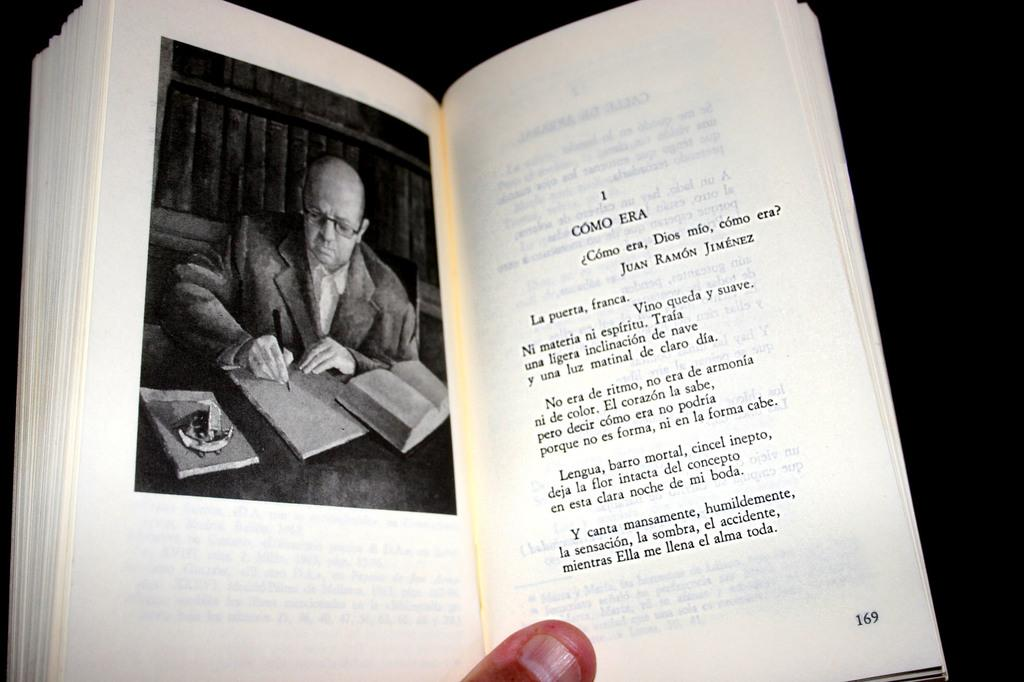<image>
Offer a succinct explanation of the picture presented. An open French book showing a picture of a man writing on one page and the chapter title Como Era on the other. 